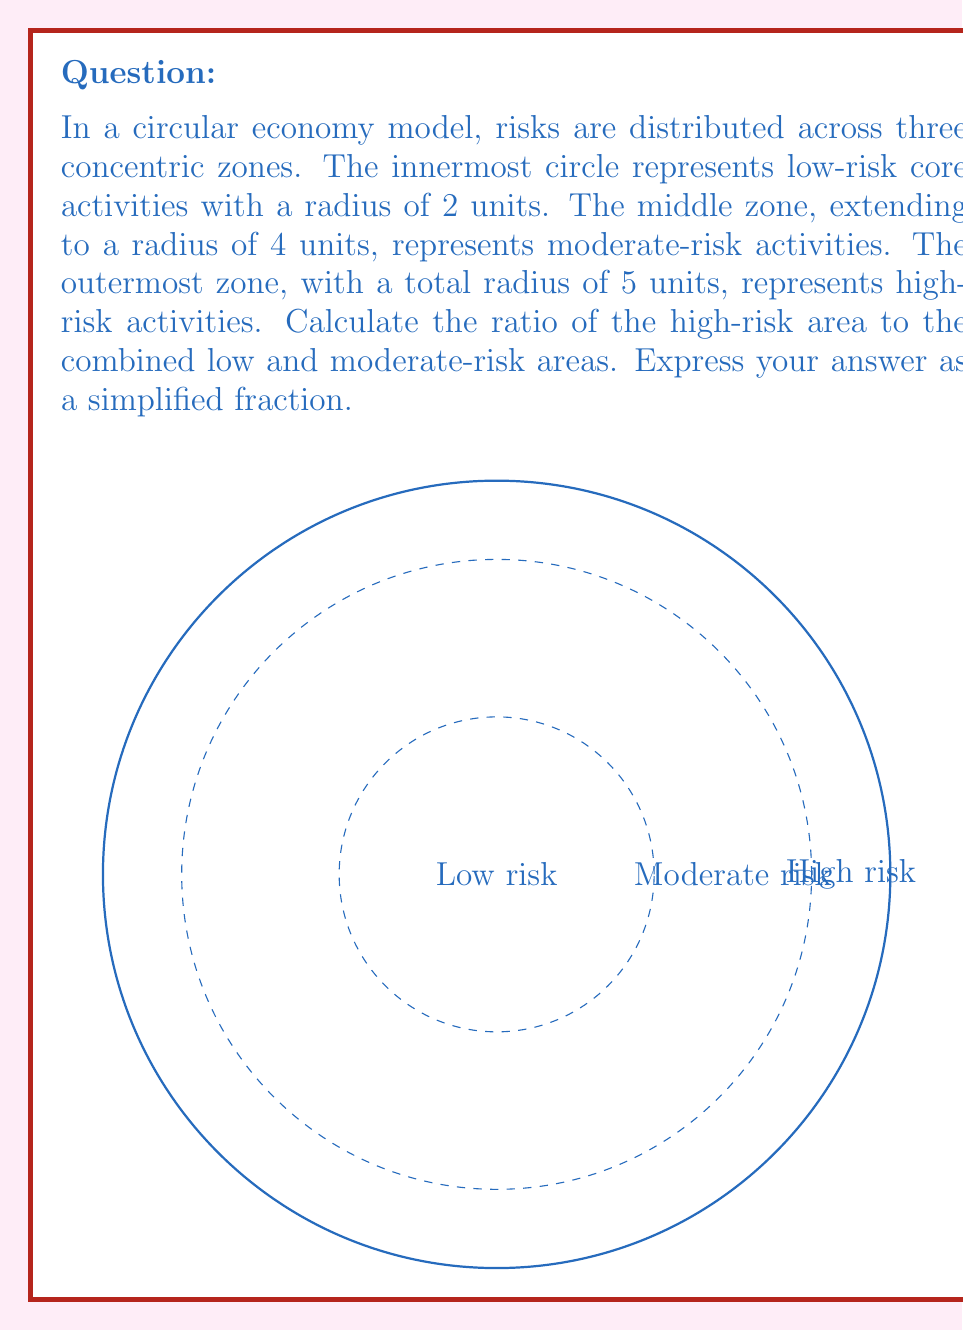Can you answer this question? Let's approach this step-by-step:

1) First, recall the formula for the area of a circle: $A = \pi r^2$

2) Calculate the areas of each zone:
   - Low-risk zone (inner circle): $A_1 = \pi (2^2) = 4\pi$
   - Moderate-risk zone (middle ring): $A_2 = \pi (4^2) - \pi (2^2) = 16\pi - 4\pi = 12\pi$
   - High-risk zone (outer ring): $A_3 = \pi (5^2) - \pi (4^2) = 25\pi - 16\pi = 9\pi$

3) The combined area of low and moderate-risk zones:
   $A_{1+2} = A_1 + A_2 = 4\pi + 12\pi = 16\pi$

4) The ratio of high-risk area to combined low and moderate-risk areas:
   $$\frac{A_3}{A_{1+2}} = \frac{9\pi}{16\pi}$$

5) Simplify the fraction:
   $$\frac{9\pi}{16\pi} = \frac{9}{16}$$

This ratio indicates that the high-risk area is $\frac{9}{16}$ of the combined low and moderate-risk areas, allowing for a balanced assessment of risk distribution in this circular economy model.
Answer: $\frac{9}{16}$ 